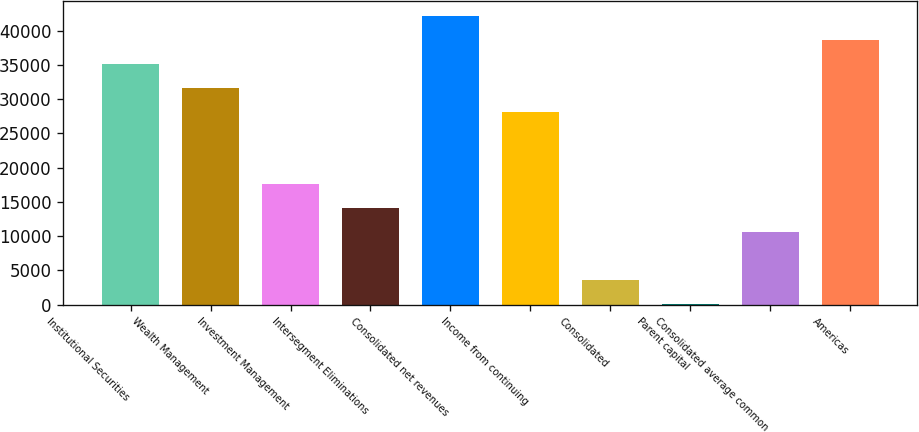Convert chart to OTSL. <chart><loc_0><loc_0><loc_500><loc_500><bar_chart><fcel>Institutional Securities<fcel>Wealth Management<fcel>Investment Management<fcel>Intersegment Eliminations<fcel>Consolidated net revenues<fcel>Income from continuing<fcel>Consolidated<fcel>Parent capital<fcel>Consolidated average common<fcel>Americas<nl><fcel>35155<fcel>31641.4<fcel>17587<fcel>14073.3<fcel>42182.2<fcel>28127.8<fcel>3532.51<fcel>18.9<fcel>10559.7<fcel>38668.6<nl></chart> 